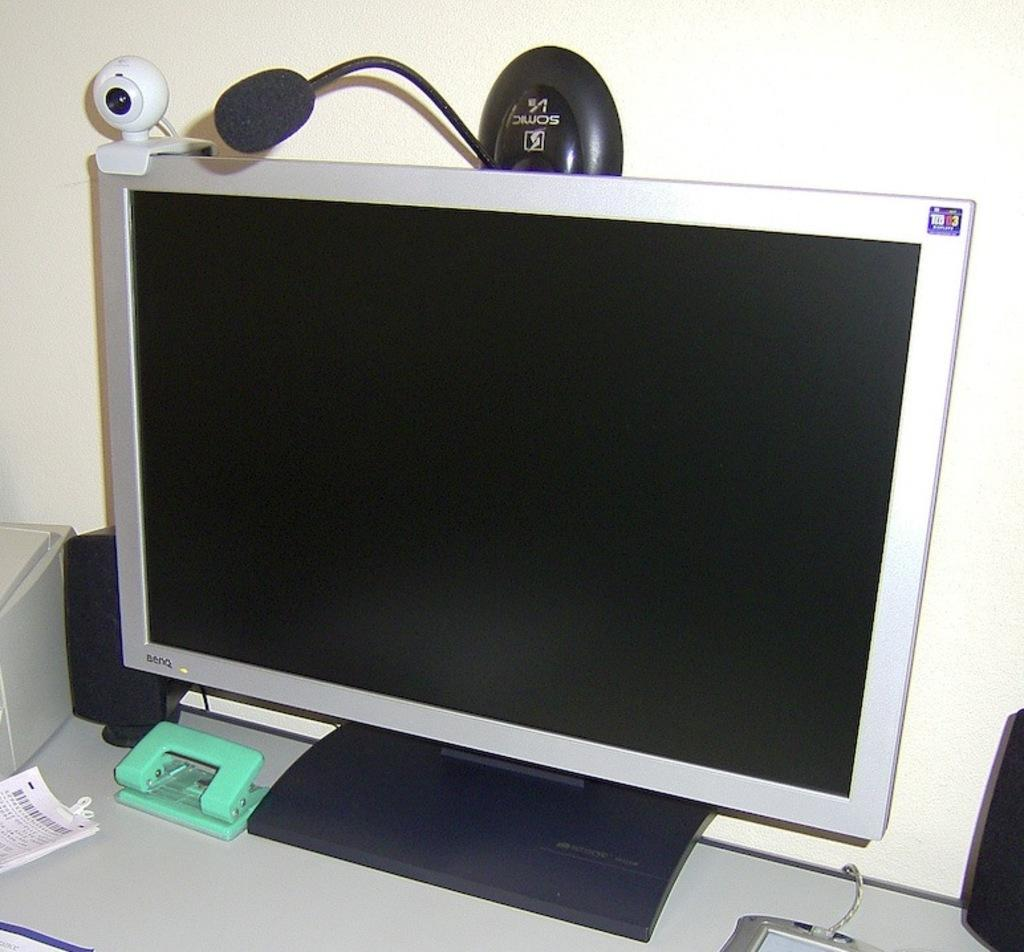<image>
Create a compact narrative representing the image presented. A BENQ computer with a webcam and microphone. 